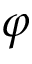<formula> <loc_0><loc_0><loc_500><loc_500>\varphi</formula> 